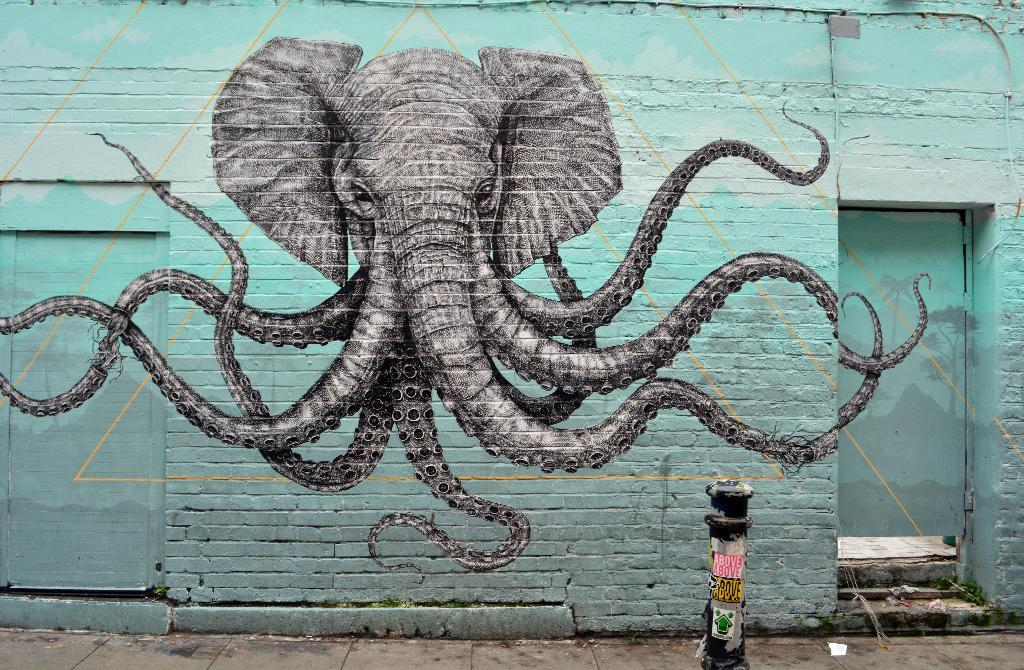What is depicted in the painting that is visible in the image? There is a painting of an elephant in the image. Where is the painting located? The painting is on a brick wall. What color is the brick wall? The brick wall has a blue color. How many doors are on the brick wall? There are two doors on the brick wall. What can be seen on the right side of the image? There is a small pole on the right side of the image. What type of haircut does the elephant have in the painting? The painting is of an elephant, and elephants do not have haircuts. The image does not depict any haircuts. 